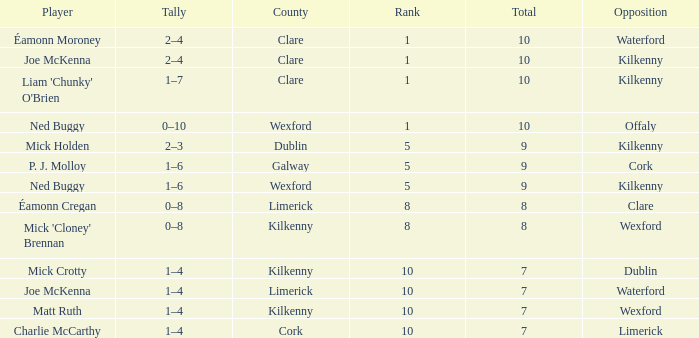Which Total has a County of kilkenny, and a Tally of 1–4, and a Rank larger than 10? None. 